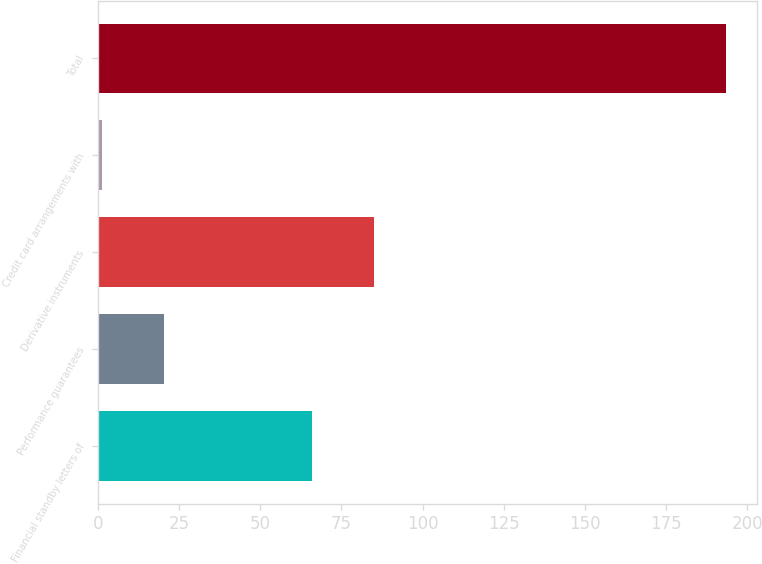<chart> <loc_0><loc_0><loc_500><loc_500><bar_chart><fcel>Financial standby letters of<fcel>Performance guarantees<fcel>Derivative instruments<fcel>Credit card arrangements with<fcel>Total<nl><fcel>65.9<fcel>20.33<fcel>85.13<fcel>1.1<fcel>193.4<nl></chart> 